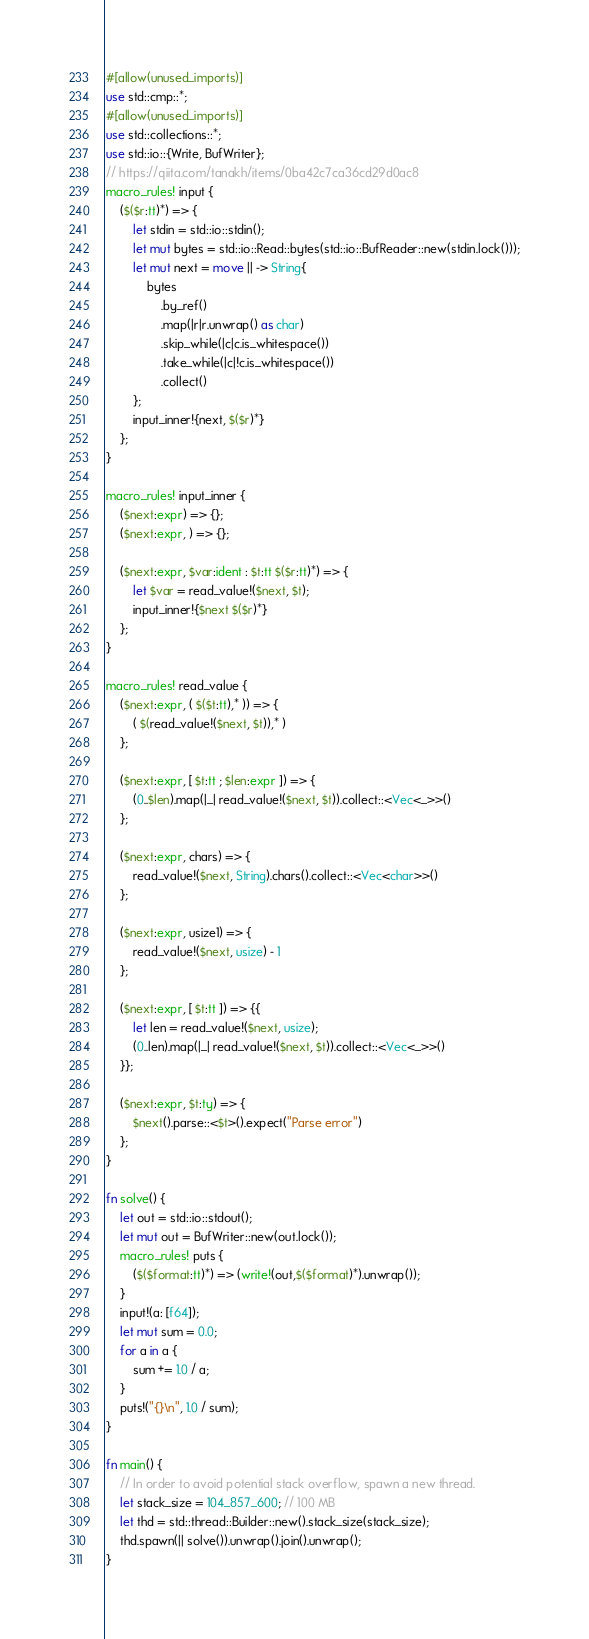<code> <loc_0><loc_0><loc_500><loc_500><_Rust_>#[allow(unused_imports)]
use std::cmp::*;
#[allow(unused_imports)]
use std::collections::*;
use std::io::{Write, BufWriter};
// https://qiita.com/tanakh/items/0ba42c7ca36cd29d0ac8
macro_rules! input {
    ($($r:tt)*) => {
        let stdin = std::io::stdin();
        let mut bytes = std::io::Read::bytes(std::io::BufReader::new(stdin.lock()));
        let mut next = move || -> String{
            bytes
                .by_ref()
                .map(|r|r.unwrap() as char)
                .skip_while(|c|c.is_whitespace())
                .take_while(|c|!c.is_whitespace())
                .collect()
        };
        input_inner!{next, $($r)*}
    };
}

macro_rules! input_inner {
    ($next:expr) => {};
    ($next:expr, ) => {};

    ($next:expr, $var:ident : $t:tt $($r:tt)*) => {
        let $var = read_value!($next, $t);
        input_inner!{$next $($r)*}
    };
}

macro_rules! read_value {
    ($next:expr, ( $($t:tt),* )) => {
        ( $(read_value!($next, $t)),* )
    };

    ($next:expr, [ $t:tt ; $len:expr ]) => {
        (0..$len).map(|_| read_value!($next, $t)).collect::<Vec<_>>()
    };

    ($next:expr, chars) => {
        read_value!($next, String).chars().collect::<Vec<char>>()
    };

    ($next:expr, usize1) => {
        read_value!($next, usize) - 1
    };

    ($next:expr, [ $t:tt ]) => {{
        let len = read_value!($next, usize);
        (0..len).map(|_| read_value!($next, $t)).collect::<Vec<_>>()
    }};

    ($next:expr, $t:ty) => {
        $next().parse::<$t>().expect("Parse error")
    };
}

fn solve() {
    let out = std::io::stdout();
    let mut out = BufWriter::new(out.lock());
    macro_rules! puts {
        ($($format:tt)*) => (write!(out,$($format)*).unwrap());
    }
    input!(a: [f64]);
    let mut sum = 0.0;
    for a in a {
        sum += 1.0 / a;
    }
    puts!("{}\n", 1.0 / sum);
}

fn main() {
    // In order to avoid potential stack overflow, spawn a new thread.
    let stack_size = 104_857_600; // 100 MB
    let thd = std::thread::Builder::new().stack_size(stack_size);
    thd.spawn(|| solve()).unwrap().join().unwrap();
}
</code> 